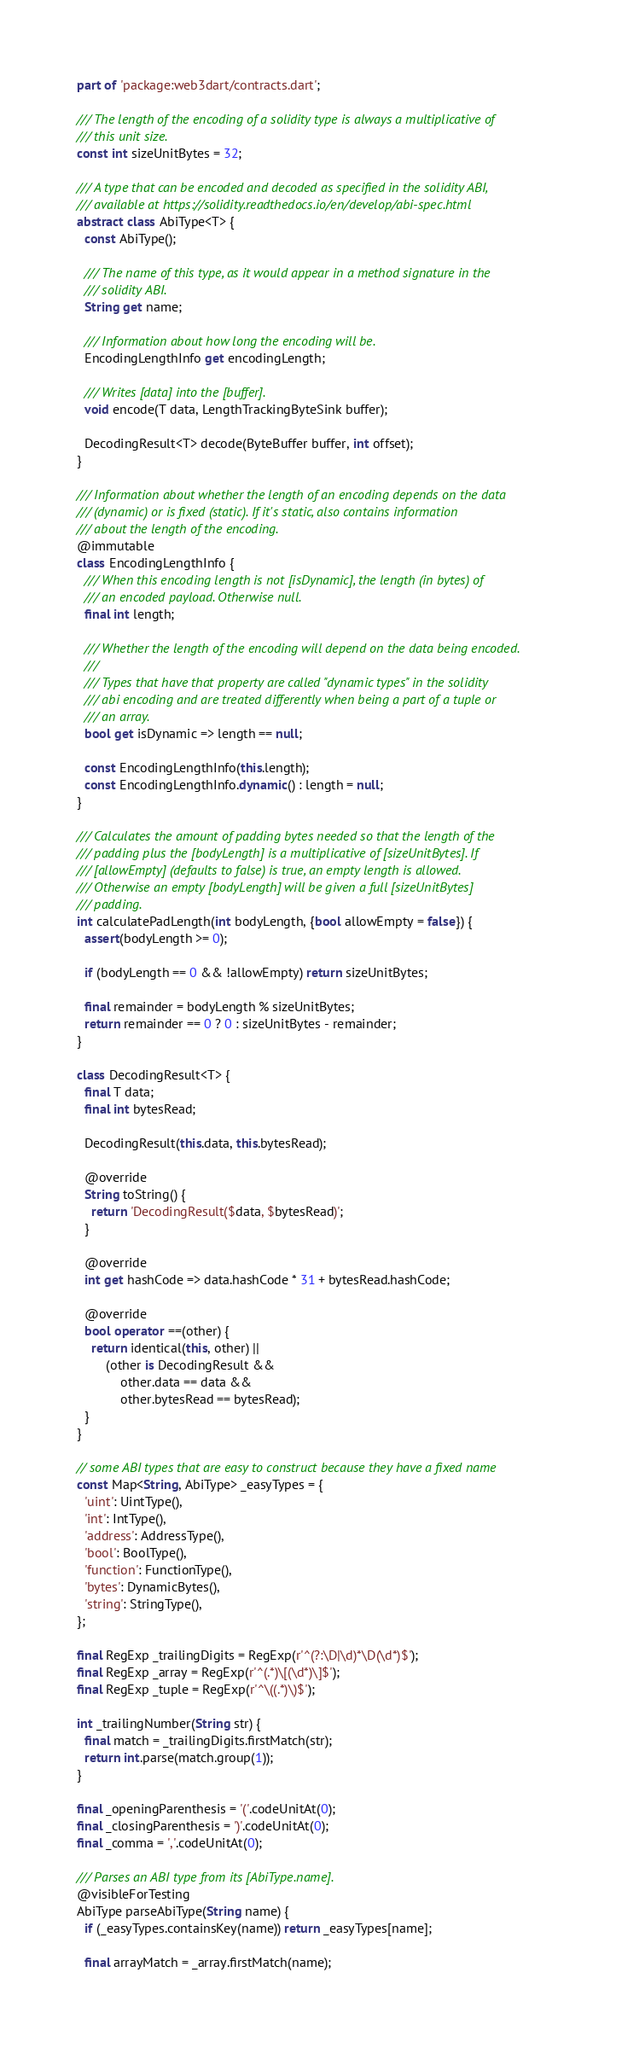Convert code to text. <code><loc_0><loc_0><loc_500><loc_500><_Dart_>part of 'package:web3dart/contracts.dart';

/// The length of the encoding of a solidity type is always a multiplicative of
/// this unit size.
const int sizeUnitBytes = 32;

/// A type that can be encoded and decoded as specified in the solidity ABI,
/// available at https://solidity.readthedocs.io/en/develop/abi-spec.html
abstract class AbiType<T> {
  const AbiType();

  /// The name of this type, as it would appear in a method signature in the
  /// solidity ABI.
  String get name;

  /// Information about how long the encoding will be.
  EncodingLengthInfo get encodingLength;

  /// Writes [data] into the [buffer].
  void encode(T data, LengthTrackingByteSink buffer);

  DecodingResult<T> decode(ByteBuffer buffer, int offset);
}

/// Information about whether the length of an encoding depends on the data
/// (dynamic) or is fixed (static). If it's static, also contains information
/// about the length of the encoding.
@immutable
class EncodingLengthInfo {
  /// When this encoding length is not [isDynamic], the length (in bytes) of
  /// an encoded payload. Otherwise null.
  final int length;

  /// Whether the length of the encoding will depend on the data being encoded.
  ///
  /// Types that have that property are called "dynamic types" in the solidity
  /// abi encoding and are treated differently when being a part of a tuple or
  /// an array.
  bool get isDynamic => length == null;

  const EncodingLengthInfo(this.length);
  const EncodingLengthInfo.dynamic() : length = null;
}

/// Calculates the amount of padding bytes needed so that the length of the
/// padding plus the [bodyLength] is a multiplicative of [sizeUnitBytes]. If
/// [allowEmpty] (defaults to false) is true, an empty length is allowed.
/// Otherwise an empty [bodyLength] will be given a full [sizeUnitBytes]
/// padding.
int calculatePadLength(int bodyLength, {bool allowEmpty = false}) {
  assert(bodyLength >= 0);

  if (bodyLength == 0 && !allowEmpty) return sizeUnitBytes;

  final remainder = bodyLength % sizeUnitBytes;
  return remainder == 0 ? 0 : sizeUnitBytes - remainder;
}

class DecodingResult<T> {
  final T data;
  final int bytesRead;

  DecodingResult(this.data, this.bytesRead);

  @override
  String toString() {
    return 'DecodingResult($data, $bytesRead)';
  }

  @override
  int get hashCode => data.hashCode * 31 + bytesRead.hashCode;

  @override
  bool operator ==(other) {
    return identical(this, other) ||
        (other is DecodingResult &&
            other.data == data &&
            other.bytesRead == bytesRead);
  }
}

// some ABI types that are easy to construct because they have a fixed name
const Map<String, AbiType> _easyTypes = {
  'uint': UintType(),
  'int': IntType(),
  'address': AddressType(),
  'bool': BoolType(),
  'function': FunctionType(),
  'bytes': DynamicBytes(),
  'string': StringType(),
};

final RegExp _trailingDigits = RegExp(r'^(?:\D|\d)*\D(\d*)$');
final RegExp _array = RegExp(r'^(.*)\[(\d*)\]$');
final RegExp _tuple = RegExp(r'^\((.*)\)$');

int _trailingNumber(String str) {
  final match = _trailingDigits.firstMatch(str);
  return int.parse(match.group(1));
}

final _openingParenthesis = '('.codeUnitAt(0);
final _closingParenthesis = ')'.codeUnitAt(0);
final _comma = ','.codeUnitAt(0);

/// Parses an ABI type from its [AbiType.name].
@visibleForTesting
AbiType parseAbiType(String name) {
  if (_easyTypes.containsKey(name)) return _easyTypes[name];

  final arrayMatch = _array.firstMatch(name);</code> 